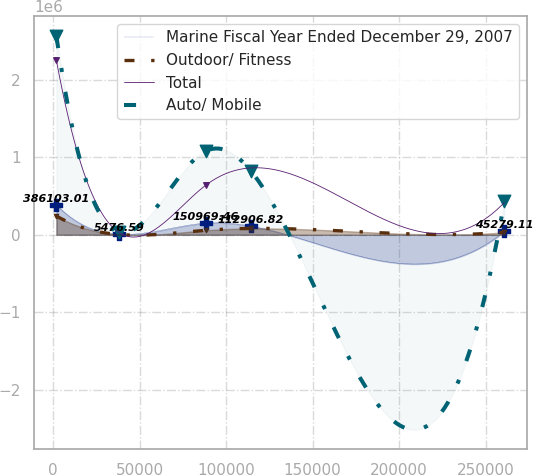Convert chart to OTSL. <chart><loc_0><loc_0><loc_500><loc_500><line_chart><ecel><fcel>Marine Fiscal Year Ended December 29, 2007<fcel>Outdoor/ Fitness<fcel>Total<fcel>Auto/ Mobile<nl><fcel>1959.72<fcel>386103<fcel>241399<fcel>2.2484e+06<fcel>2.5612e+06<nl><fcel>38206.1<fcel>5476.59<fcel>3477.28<fcel>28395.1<fcel>35712.3<nl><fcel>88344.6<fcel>150969<fcel>58003.2<fcel>640563<fcel>1.08028e+06<nl><fcel>114236<fcel>112907<fcel>81795.4<fcel>862564<fcel>826214<nl><fcel>260877<fcel>45279.1<fcel>32350.5<fcel>418563<fcel>439253<nl></chart> 